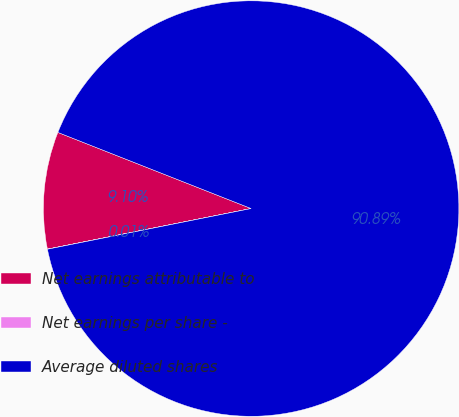Convert chart to OTSL. <chart><loc_0><loc_0><loc_500><loc_500><pie_chart><fcel>Net earnings attributable to<fcel>Net earnings per share -<fcel>Average diluted shares<nl><fcel>9.1%<fcel>0.01%<fcel>90.88%<nl></chart> 